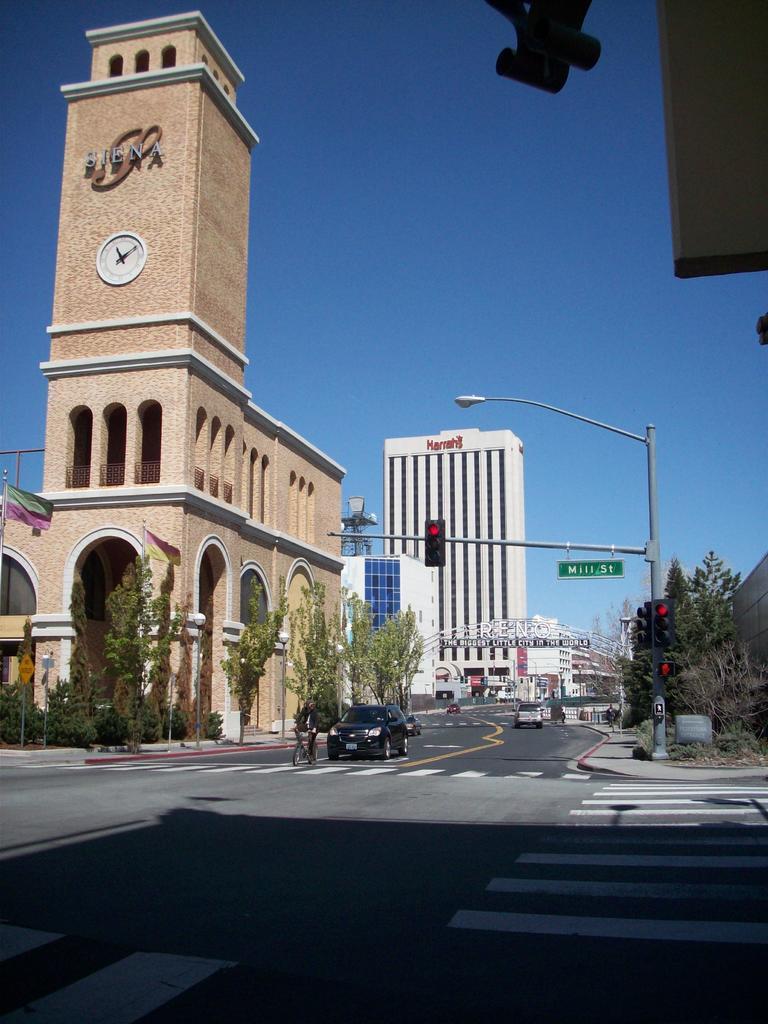Describe this image in one or two sentences. In this image we can see a few buildings and trees, there are some vehicles on the road, among those vehicles one person is riding a bicycle, we can see some poles, lights, flags, wall clock and the wall. 